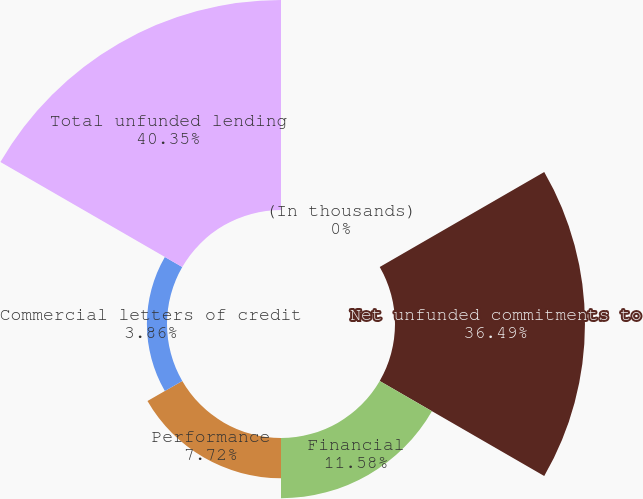Convert chart. <chart><loc_0><loc_0><loc_500><loc_500><pie_chart><fcel>(In thousands)<fcel>Net unfunded commitments to<fcel>Financial<fcel>Performance<fcel>Commercial letters of credit<fcel>Total unfunded lending<nl><fcel>0.0%<fcel>36.49%<fcel>11.58%<fcel>7.72%<fcel>3.86%<fcel>40.34%<nl></chart> 